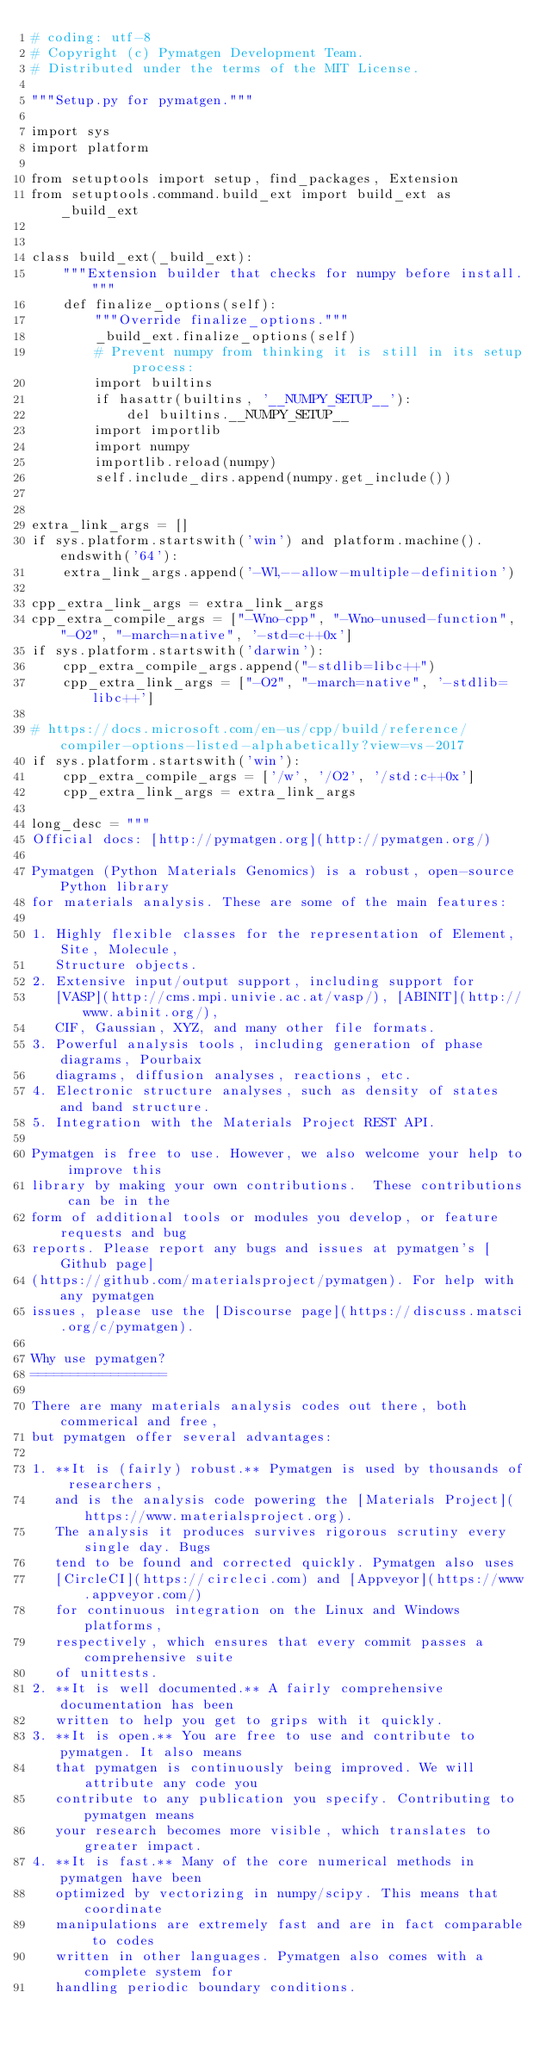Convert code to text. <code><loc_0><loc_0><loc_500><loc_500><_Python_># coding: utf-8
# Copyright (c) Pymatgen Development Team.
# Distributed under the terms of the MIT License.

"""Setup.py for pymatgen."""

import sys
import platform

from setuptools import setup, find_packages, Extension
from setuptools.command.build_ext import build_ext as _build_ext


class build_ext(_build_ext):
    """Extension builder that checks for numpy before install."""
    def finalize_options(self):
        """Override finalize_options."""
        _build_ext.finalize_options(self)
        # Prevent numpy from thinking it is still in its setup process:
        import builtins
        if hasattr(builtins, '__NUMPY_SETUP__'):
            del builtins.__NUMPY_SETUP__
        import importlib
        import numpy
        importlib.reload(numpy)
        self.include_dirs.append(numpy.get_include())


extra_link_args = []
if sys.platform.startswith('win') and platform.machine().endswith('64'):
    extra_link_args.append('-Wl,--allow-multiple-definition')

cpp_extra_link_args = extra_link_args
cpp_extra_compile_args = ["-Wno-cpp", "-Wno-unused-function", "-O2", "-march=native", '-std=c++0x']
if sys.platform.startswith('darwin'):
    cpp_extra_compile_args.append("-stdlib=libc++")
    cpp_extra_link_args = ["-O2", "-march=native", '-stdlib=libc++']

# https://docs.microsoft.com/en-us/cpp/build/reference/compiler-options-listed-alphabetically?view=vs-2017
if sys.platform.startswith('win'):
    cpp_extra_compile_args = ['/w', '/O2', '/std:c++0x']
    cpp_extra_link_args = extra_link_args

long_desc = """
Official docs: [http://pymatgen.org](http://pymatgen.org/)

Pymatgen (Python Materials Genomics) is a robust, open-source Python library
for materials analysis. These are some of the main features:

1. Highly flexible classes for the representation of Element, Site, Molecule,
   Structure objects.
2. Extensive input/output support, including support for
   [VASP](http://cms.mpi.univie.ac.at/vasp/), [ABINIT](http://www.abinit.org/),
   CIF, Gaussian, XYZ, and many other file formats.
3. Powerful analysis tools, including generation of phase diagrams, Pourbaix
   diagrams, diffusion analyses, reactions, etc.
4. Electronic structure analyses, such as density of states and band structure.
5. Integration with the Materials Project REST API.

Pymatgen is free to use. However, we also welcome your help to improve this
library by making your own contributions.  These contributions can be in the
form of additional tools or modules you develop, or feature requests and bug
reports. Please report any bugs and issues at pymatgen's [Github page]
(https://github.com/materialsproject/pymatgen). For help with any pymatgen
issues, please use the [Discourse page](https://discuss.matsci.org/c/pymatgen).

Why use pymatgen?
=================

There are many materials analysis codes out there, both commerical and free,
but pymatgen offer several advantages:

1. **It is (fairly) robust.** Pymatgen is used by thousands of researchers,
   and is the analysis code powering the [Materials Project](https://www.materialsproject.org).
   The analysis it produces survives rigorous scrutiny every single day. Bugs
   tend to be found and corrected quickly. Pymatgen also uses
   [CircleCI](https://circleci.com) and [Appveyor](https://www.appveyor.com/)
   for continuous integration on the Linux and Windows platforms,
   respectively, which ensures that every commit passes a comprehensive suite
   of unittests.
2. **It is well documented.** A fairly comprehensive documentation has been
   written to help you get to grips with it quickly.
3. **It is open.** You are free to use and contribute to pymatgen. It also means
   that pymatgen is continuously being improved. We will attribute any code you
   contribute to any publication you specify. Contributing to pymatgen means
   your research becomes more visible, which translates to greater impact.
4. **It is fast.** Many of the core numerical methods in pymatgen have been
   optimized by vectorizing in numpy/scipy. This means that coordinate
   manipulations are extremely fast and are in fact comparable to codes
   written in other languages. Pymatgen also comes with a complete system for
   handling periodic boundary conditions.</code> 